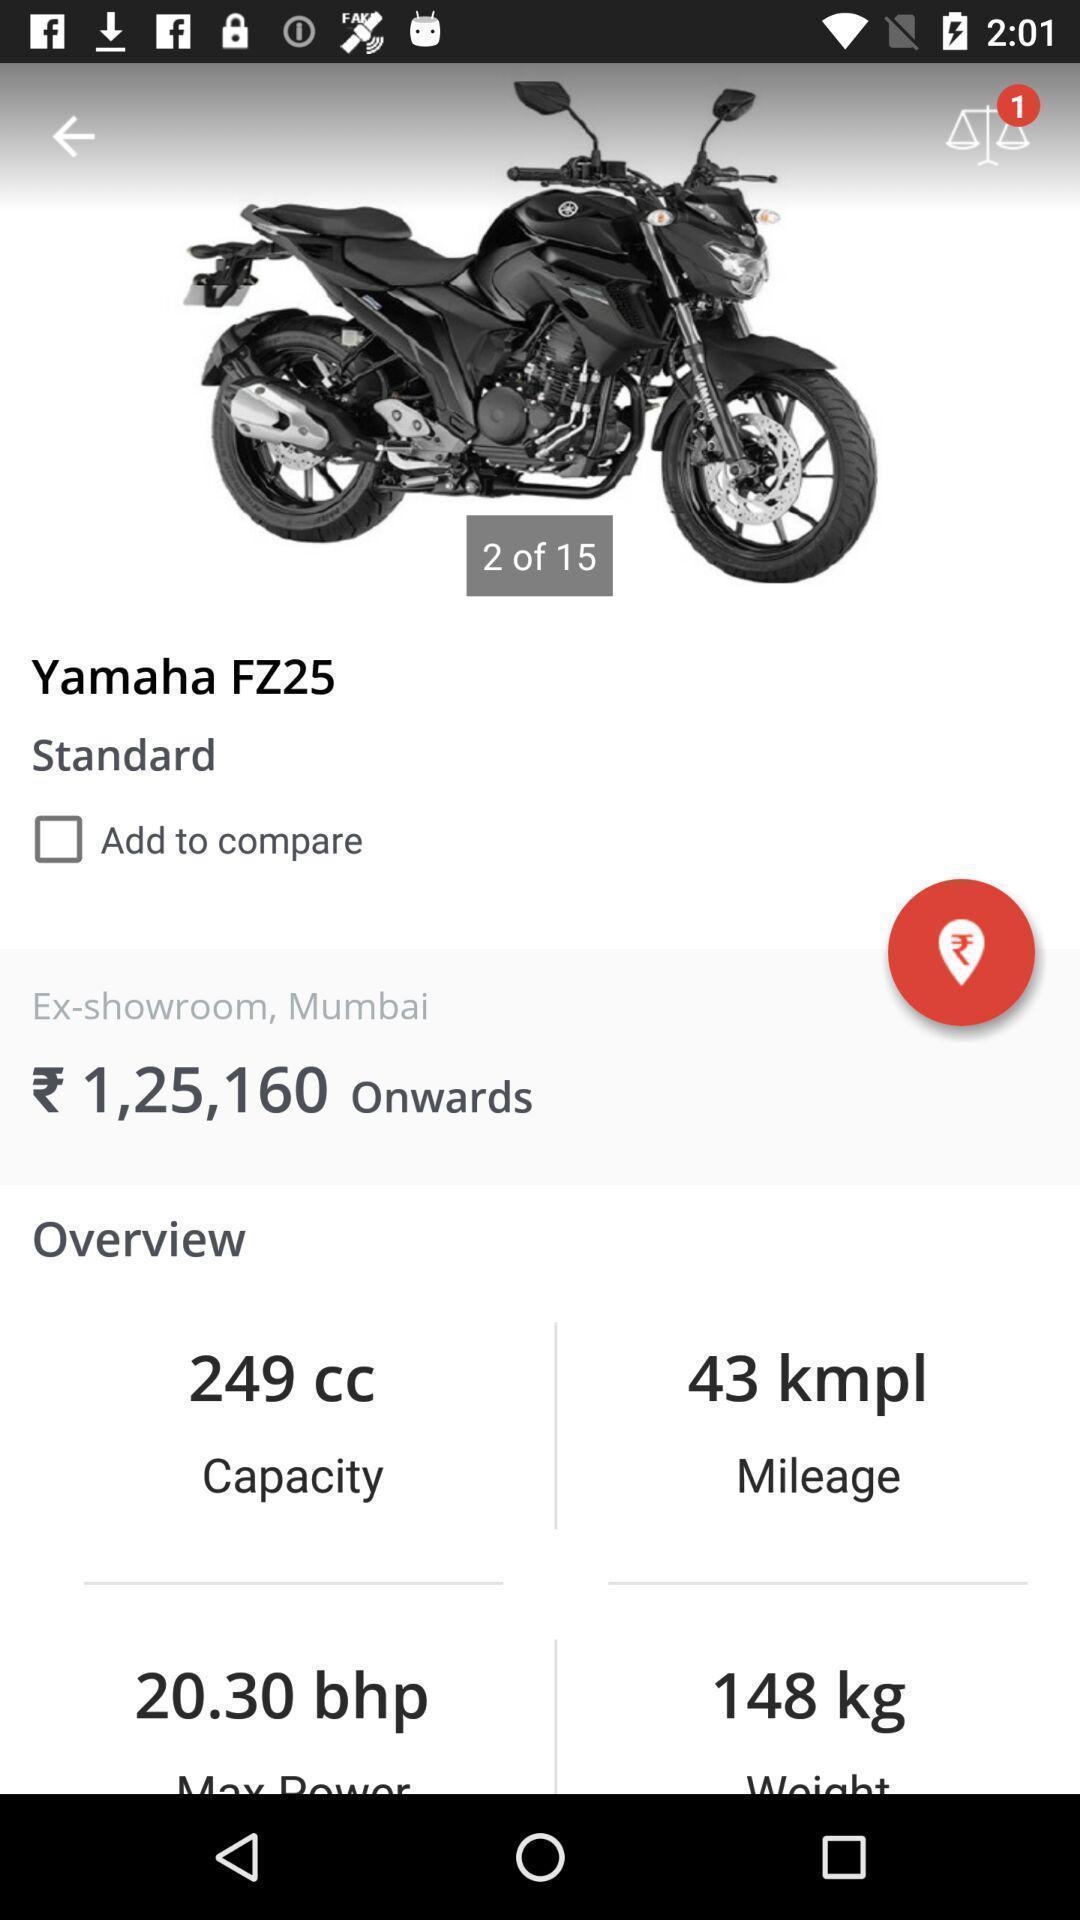Tell me what you see in this picture. Screen displaying information about the vehicle. 